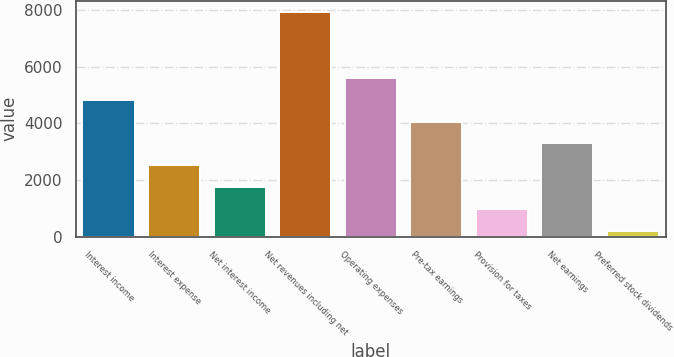Convert chart. <chart><loc_0><loc_0><loc_500><loc_500><bar_chart><fcel>Interest income<fcel>Interest expense<fcel>Net interest income<fcel>Net revenues including net<fcel>Operating expenses<fcel>Pre-tax earnings<fcel>Provision for taxes<fcel>Net earnings<fcel>Preferred stock dividends<nl><fcel>4834.4<fcel>2511.2<fcel>1736.8<fcel>7932<fcel>5608.8<fcel>4060<fcel>962.4<fcel>3285.6<fcel>188<nl></chart> 